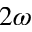Convert formula to latex. <formula><loc_0><loc_0><loc_500><loc_500>2 \omega</formula> 